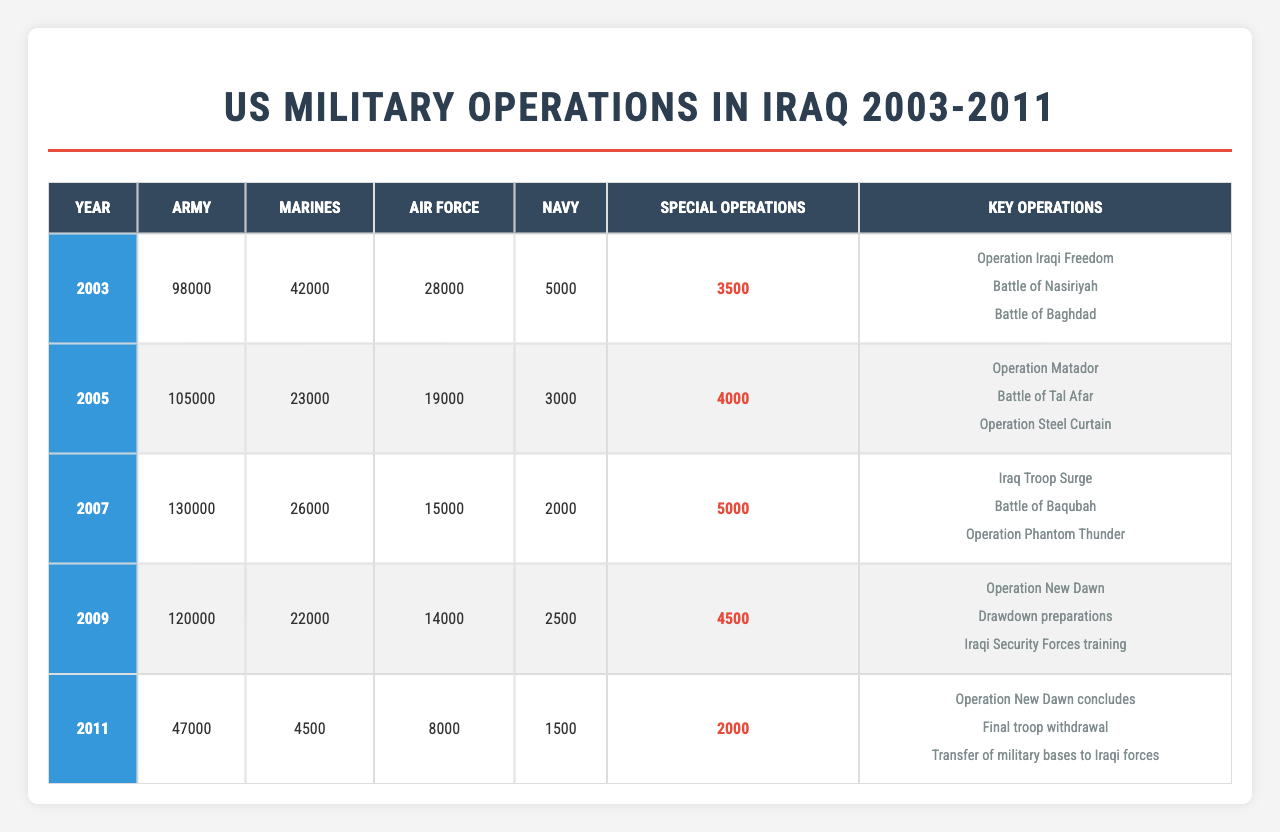What was the total number of Army troops deployed in 2007? In 2007, the number of Army troops deployed is stated directly in the table as 130,000.
Answer: 130000 Which year had the highest number of Marine troops deployed? Looking at the data, 2003 shows 42,000 Marine troops, which is the highest number listed for any year in the table. Other years, such as 2005 and 2007, had 23,000 and 26,000 Marine troops respectively, which are lower.
Answer: 2003 How many Special Operations troops were deployed in total from 2003 to 2011? Summing the values for Special Operations troops for each year from the table: 3500 (2003) + 4000 (2005) + 5000 (2007) + 4500 (2009) + 2000 (2011) gives a total of 18500.
Answer: 18500 Did the number of Navy troops decrease from 2003 to 2011? From the table, we see Navy troops were 5000 in 2003 and 1500 in 2011. This indicates a decrease since 1500 is less than 5000.
Answer: Yes In which year was the Army troop count less than the Marine troop count? The table shows that in 2003, the Army count was 98,000 while the Marine count was 42,000. In 2005, the Army count was 105,000, and the Marine count was 23,000. However, in 2011, the Army had 47,000, and Marines had 4,500, which is still more than the Marines. The answer is none of the years show the Army count to be less than Marine count.
Answer: None What is the average number of Air Force troops deployed per year over the entire period? To find the average, we sum the Air Force deployments: 28,000 (2003) + 19,000 (2005) + 15,000 (2007) + 14,000 (2009) + 8,000 (2011) = 84,000. There are 5 years, so we divide 84,000 by 5, giving us 16,800 as the average number of Air Force troops deployed per year.
Answer: 16800 What were the key operations in 2009? The table lists three key operations for 2009: "Operation New Dawn," "Drawdown preparations," and "Iraqi Security Forces training." These are clearly mentioned in the table under that year.
Answer: Operation New Dawn, Drawdown preparations, Iraqi Security Forces training In which year did the number of Army troops experience a decrease from the previous year? Comparing the numbers, after 2007 with 130,000 Army troops, the next year, 2009, shows 120,000 Army troops, which is a decrease of 10,000 from 2007. Hence, 2009 is the year with a decrease.
Answer: 2009 Was the total number of troops deployed across all branches greater in 2005 or 2007? Summing troops for both years: In 2005, total troops = 105,000 (Army) + 23,000 (Marines) + 19,000 (Air Force) + 3,000 (Navy) + 4,000 (Special Operations) = 154,000. In 2007, total troops = 130,000 (Army) + 26,000 (Marines) + 15,000 (Air Force) + 2,000 (Navy) + 5,000 (Special Operations) = 178,000. Since 178,000 (2007) is greater than 154,000 (2005), 2007 is the answer.
Answer: 2007 How many troops in total were deployed in 2003 and 2005 combined? Adding the total troops: 2003 had 98,000 (Army) + 42,000 (Marines) + 28,000 (Air Force) + 5,000 (Navy) + 3,500 (Special Operations) = 176,500. For 2005, the total is 105,000 + 23,000 + 19,000 + 3,000 + 4,000 = 154,000. Combining both years gives 176,500 + 154,000 = 330,500.
Answer: 330500 